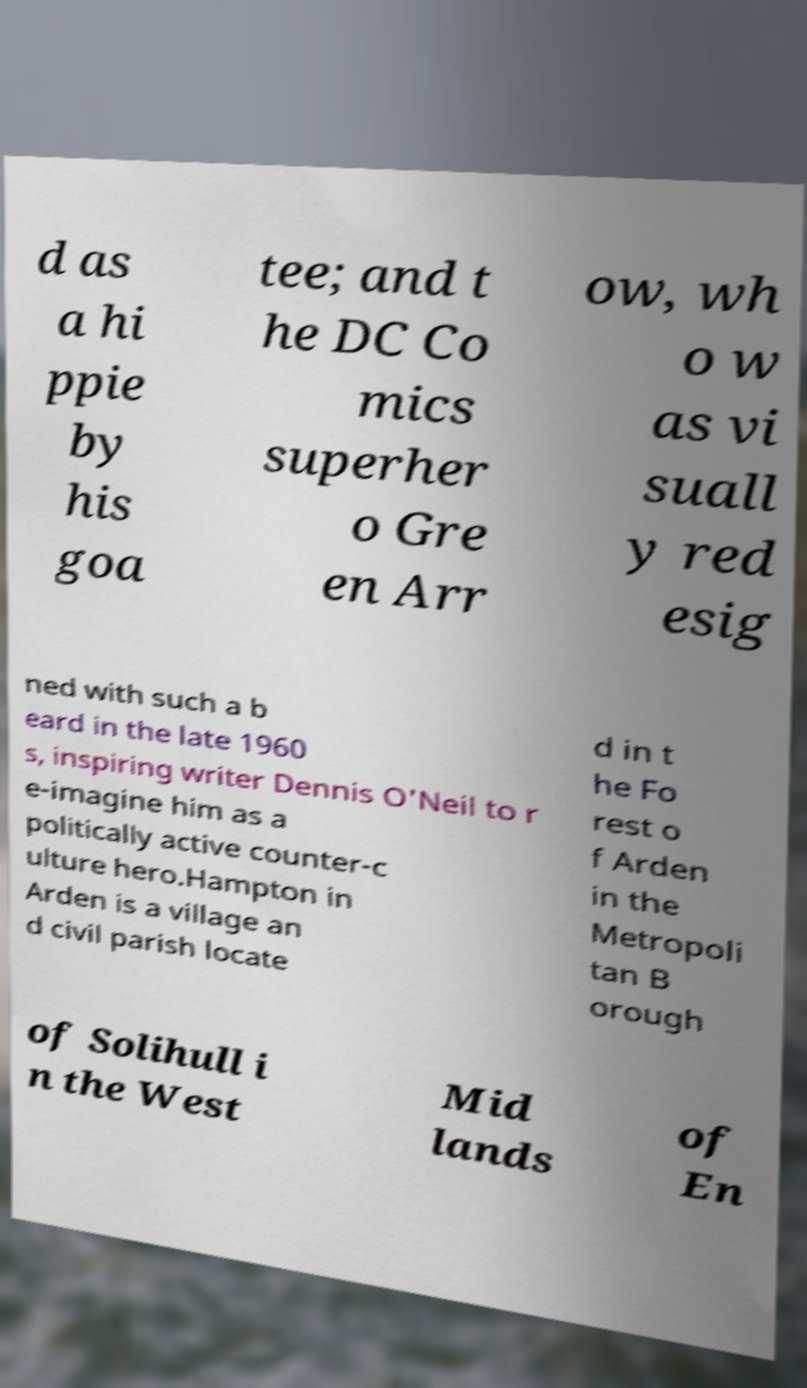What messages or text are displayed in this image? I need them in a readable, typed format. d as a hi ppie by his goa tee; and t he DC Co mics superher o Gre en Arr ow, wh o w as vi suall y red esig ned with such a b eard in the late 1960 s, inspiring writer Dennis O'Neil to r e-imagine him as a politically active counter-c ulture hero.Hampton in Arden is a village an d civil parish locate d in t he Fo rest o f Arden in the Metropoli tan B orough of Solihull i n the West Mid lands of En 